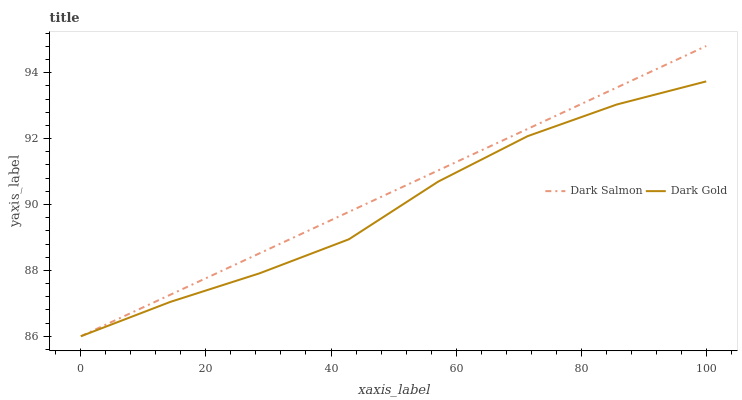Does Dark Gold have the minimum area under the curve?
Answer yes or no. Yes. Does Dark Salmon have the maximum area under the curve?
Answer yes or no. Yes. Does Dark Gold have the maximum area under the curve?
Answer yes or no. No. Is Dark Salmon the smoothest?
Answer yes or no. Yes. Is Dark Gold the roughest?
Answer yes or no. Yes. Is Dark Gold the smoothest?
Answer yes or no. No. Does Dark Salmon have the lowest value?
Answer yes or no. Yes. Does Dark Salmon have the highest value?
Answer yes or no. Yes. Does Dark Gold have the highest value?
Answer yes or no. No. Does Dark Salmon intersect Dark Gold?
Answer yes or no. Yes. Is Dark Salmon less than Dark Gold?
Answer yes or no. No. Is Dark Salmon greater than Dark Gold?
Answer yes or no. No. 